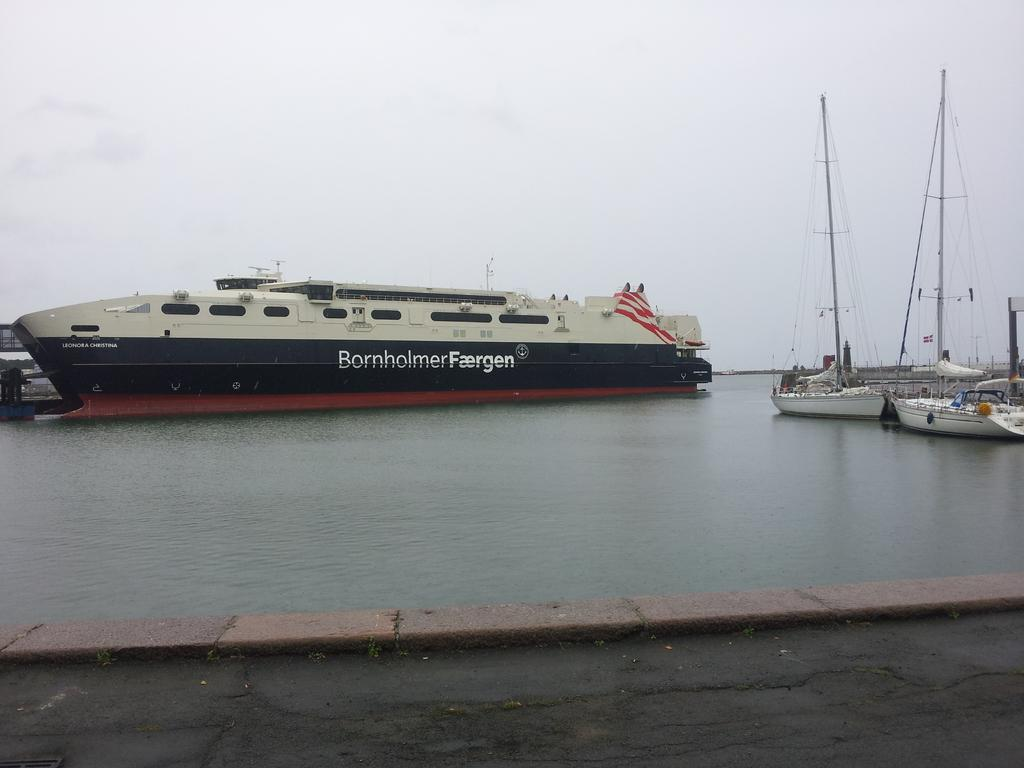<image>
Describe the image concisely. A big boat of the BornholmerFaergen company on the docks. 